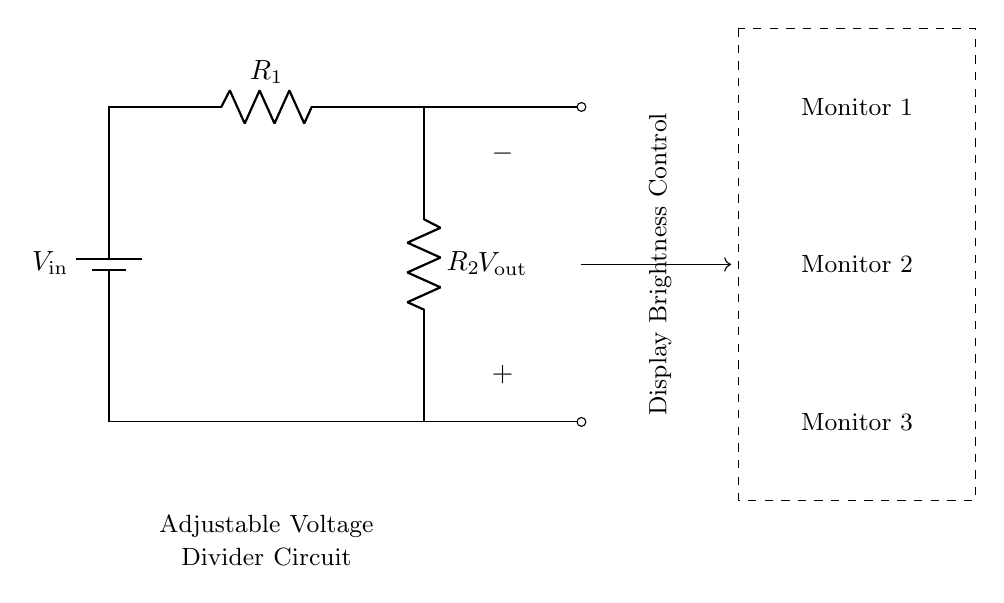What is the input voltage of this circuit? The input voltage, represented as \(V_\text{in}\) in the circuit, is the voltage source connected at the top.
Answer: \(V_\text{in}\) What are the values of the resistors in the circuit? The circuit includes two resistors labeled as \(R_1\) and \(R_2\), which are adjustable for brightness control. Specific numerical values are not provided, but they are critical for calculating the output voltage.
Answer: \(R_1\) and \(R_2\) What is the output voltage denoted as in the diagram? The output voltage is denoted as \(V_\text{out}\) and is connected to the junction between the two resistors.
Answer: \(V_\text{out}\) How does adjusting \(R_1\) or \(R_2\) affect brightness? Adjusting \(R_1\) or \(R_2\) changes the resistance ratio, which directly affects the division of input voltage, resulting in variations in output voltage, hence adjusting brightness.
Answer: It varies brightness What is the purpose of this circuit? The purpose of this circuit is to form a voltage divider that adjusts the display brightness across multiple monitors based on the output voltage.
Answer: Brightness control What happens to the output voltage if \(R_2\) is increased? Increasing \(R_2\) would increase the output voltage proportionally, given a constant \(R_1\), leading to a higher brightness setting on the monitors.
Answer: Output voltage increases What is the relationship between the output voltage and the input voltage in this circuit? The output voltage \(V_\text{out}\) is a fraction of the input voltage \(V_\text{in}\) as defined by the voltage divider formula, which involves both resistors \(R_1\) and \(R_2\).
Answer: Output voltage is a fraction 